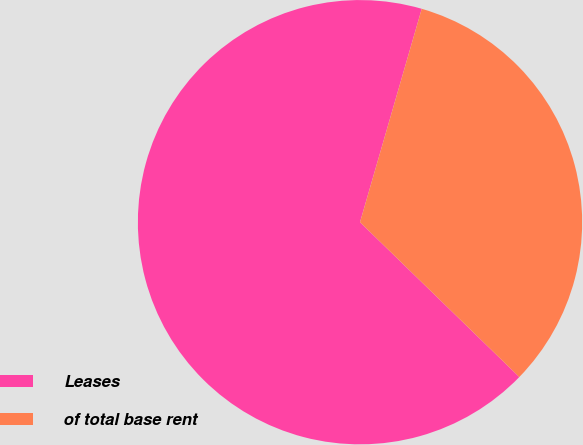Convert chart to OTSL. <chart><loc_0><loc_0><loc_500><loc_500><pie_chart><fcel>Leases<fcel>of total base rent<nl><fcel>67.21%<fcel>32.79%<nl></chart> 